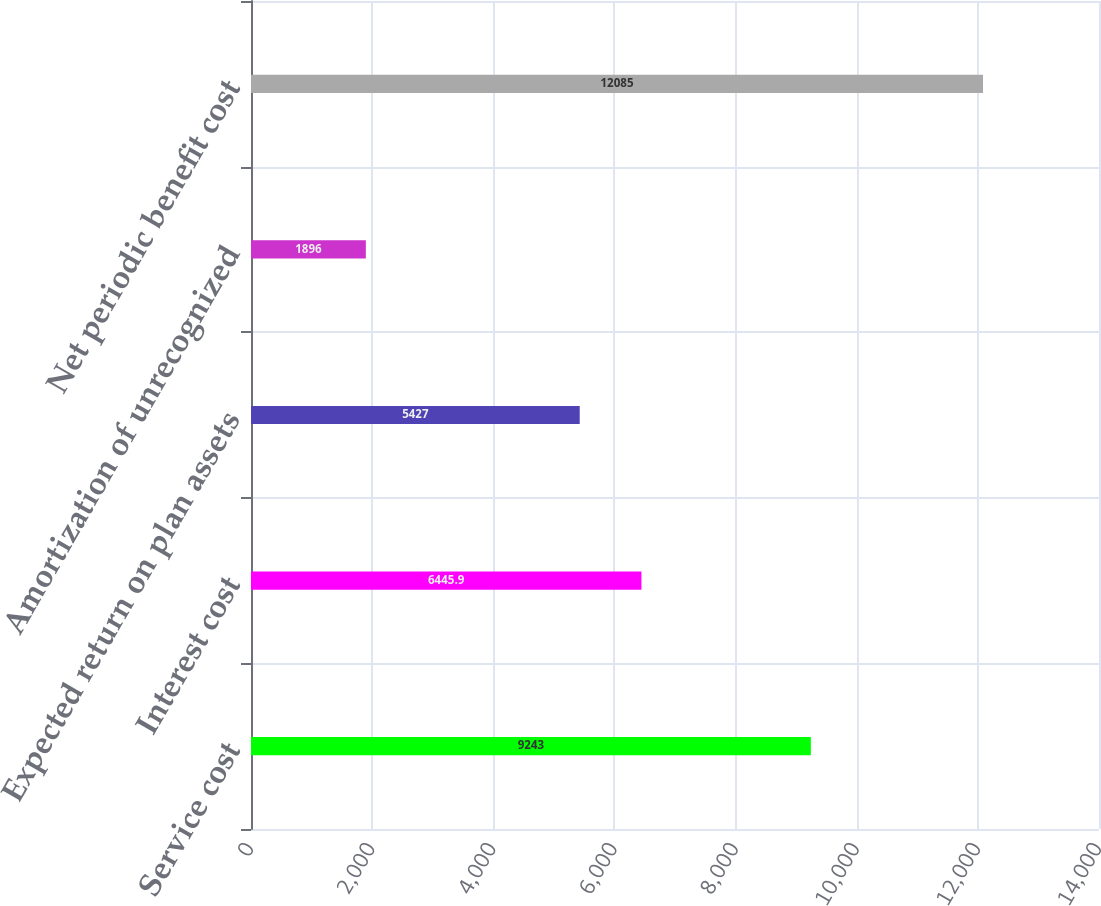Convert chart. <chart><loc_0><loc_0><loc_500><loc_500><bar_chart><fcel>Service cost<fcel>Interest cost<fcel>Expected return on plan assets<fcel>Amortization of unrecognized<fcel>Net periodic benefit cost<nl><fcel>9243<fcel>6445.9<fcel>5427<fcel>1896<fcel>12085<nl></chart> 